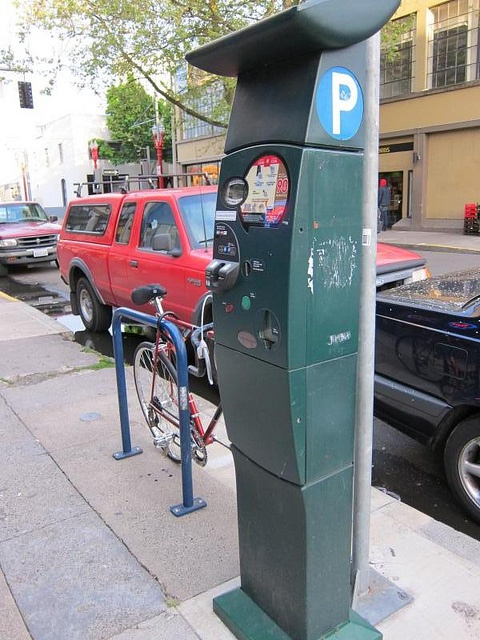Describe the objects in this image and their specific colors. I can see parking meter in white, gray, purple, and teal tones, car in white, salmon, gray, black, and brown tones, truck in white, salmon, gray, brown, and darkgray tones, car in white, black, gray, and darkgray tones, and bicycle in white, gray, lightgray, darkgray, and black tones in this image. 